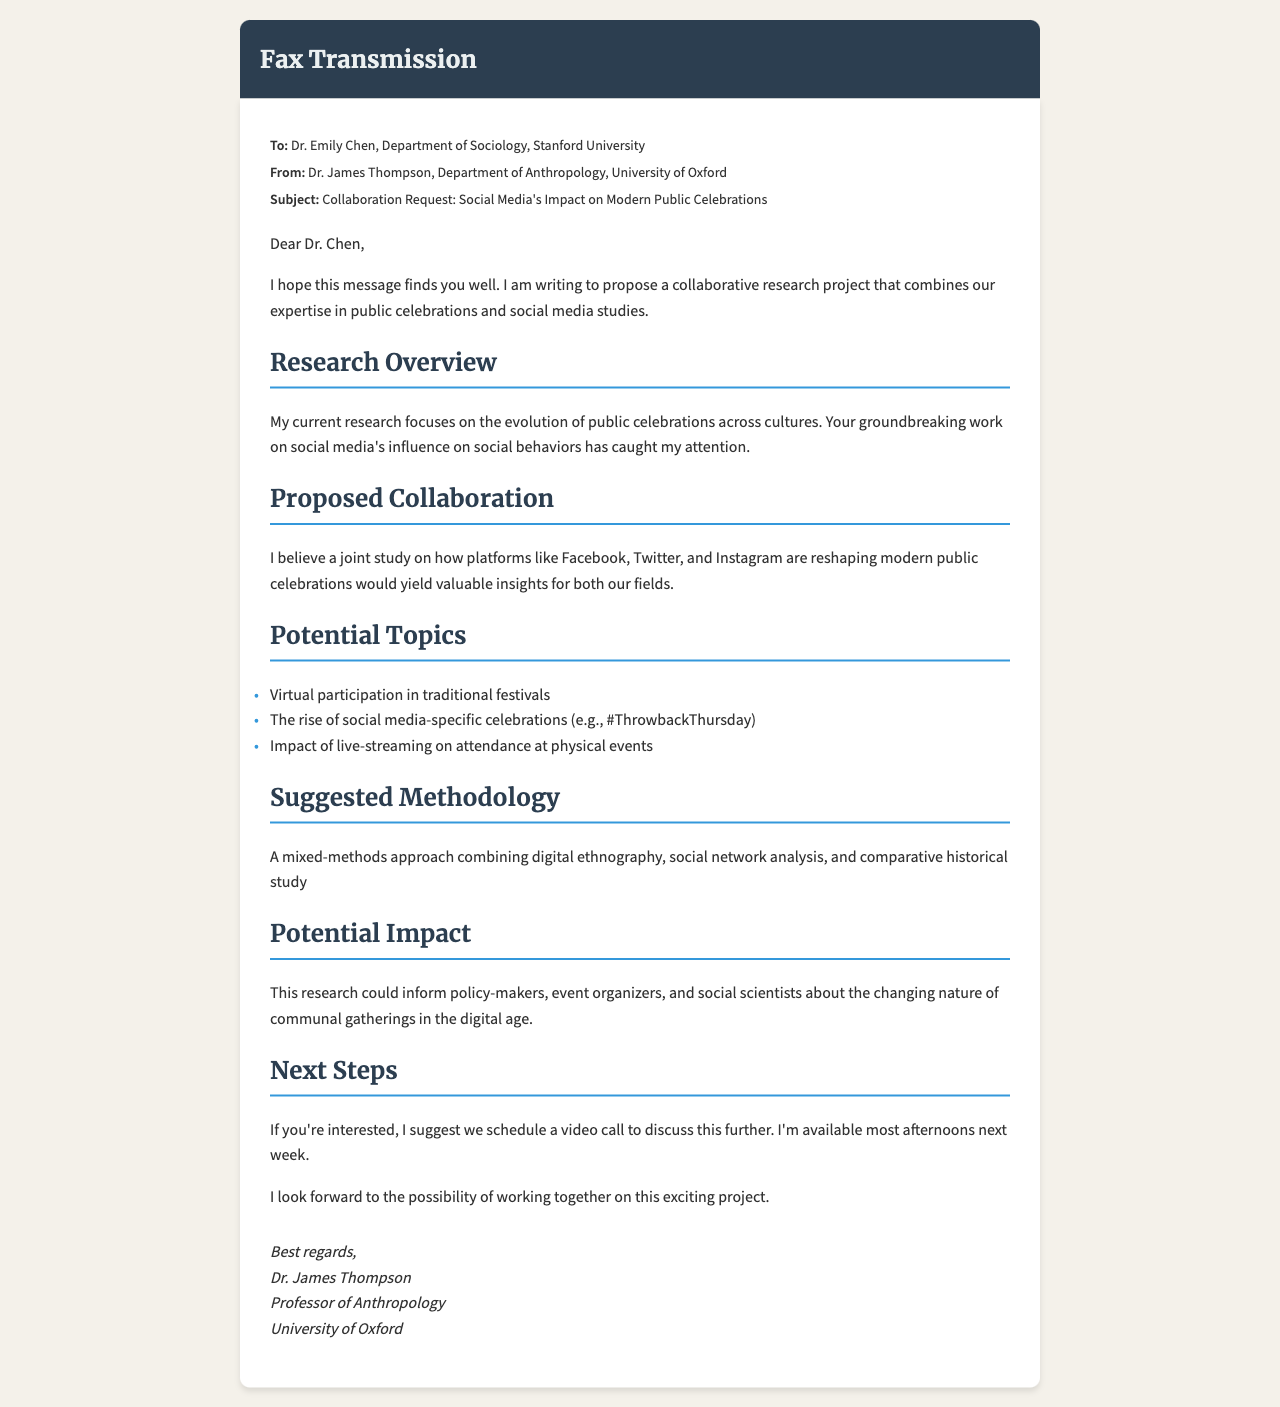what is the sender's name? The sender's name is mentioned in the introduction of the document.
Answer: Dr. James Thompson what is the recipient's title? The recipient's title is listed in the fax metadata.
Answer: Dr what is the proposed subject of collaboration? The subject of collaboration is detailed in the subject line.
Answer: Social Media's Impact on Modern Public Celebrations what is one potential topic mentioned for the research? The document lists potential topics under the "Potential Topics" section.
Answer: Virtual participation in traditional festivals what methodology is suggested for the research? The methodology is outlined under the "Suggested Methodology" section.
Answer: Mixed-methods approach who is the recipient of the fax? The recipient is identified in the fax metadata section.
Answer: Dr. Emily Chen what is suggested as the next step? The next steps are discussed towards the end of the document.
Answer: Schedule a video call what is the sender's position? The sender's position is included in the signature section of the document.
Answer: Professor of Anthropology how many potential topics are listed? The potential topics are numerically presented in the "Potential Topics" section.
Answer: Three what institution is the sender affiliated with? The sender's institution is mentioned at the end of the fax.
Answer: University of Oxford 